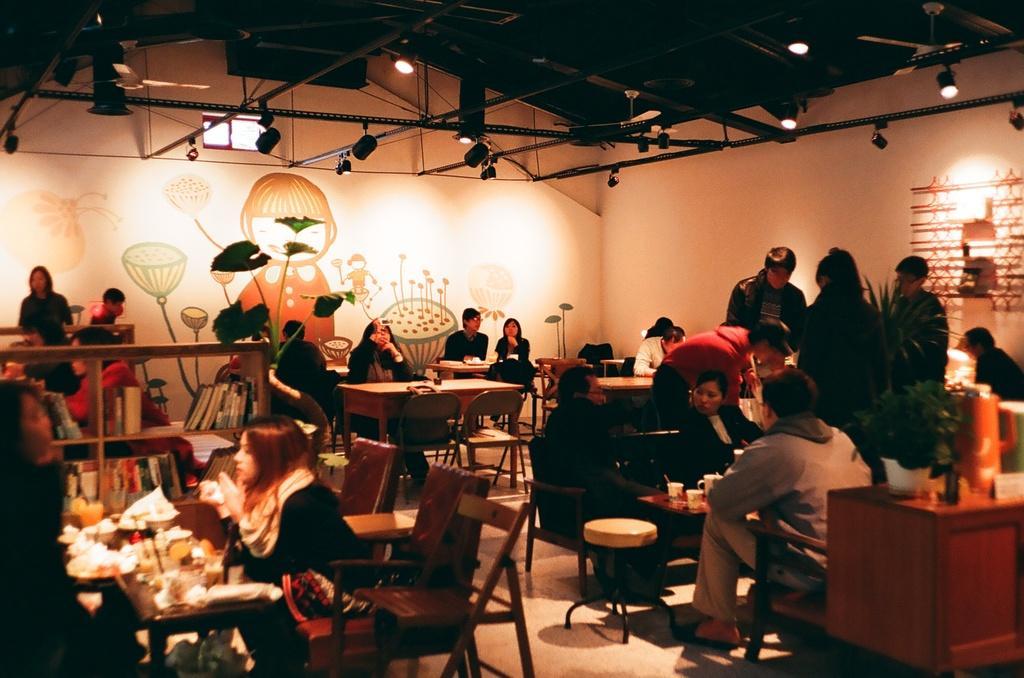Describe this image in one or two sentences. In this picture there are a group of people sitting here they have a table in front of them with some foods of Donald and onto the right there are some other tables and their a group of people standing over here and there is a wall with some painting on it and their sunlight is attached to the ceiling plant on the right side 